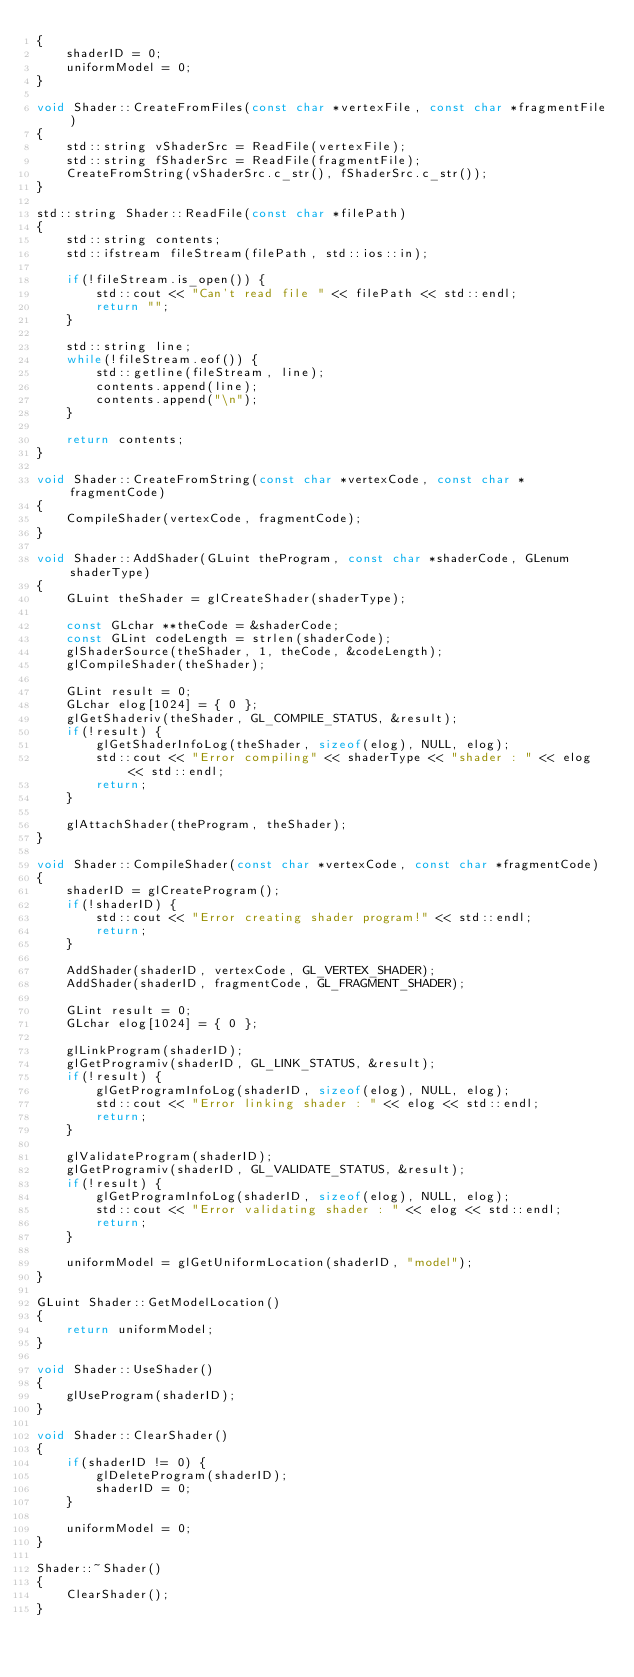<code> <loc_0><loc_0><loc_500><loc_500><_C++_>{
    shaderID = 0;
    uniformModel = 0;
}

void Shader::CreateFromFiles(const char *vertexFile, const char *fragmentFile)
{
    std::string vShaderSrc = ReadFile(vertexFile);
    std::string fShaderSrc = ReadFile(fragmentFile);
    CreateFromString(vShaderSrc.c_str(), fShaderSrc.c_str());
}

std::string Shader::ReadFile(const char *filePath)
{
    std::string contents;
    std::ifstream fileStream(filePath, std::ios::in);
    
    if(!fileStream.is_open()) {
        std::cout << "Can't read file " << filePath << std::endl;
        return "";
    }
    
    std::string line;
    while(!fileStream.eof()) {
        std::getline(fileStream, line);
        contents.append(line);
        contents.append("\n");
    }
    
    return contents;
}

void Shader::CreateFromString(const char *vertexCode, const char *fragmentCode)
{
    CompileShader(vertexCode, fragmentCode);
}

void Shader::AddShader(GLuint theProgram, const char *shaderCode, GLenum shaderType)
{
    GLuint theShader = glCreateShader(shaderType);

    const GLchar **theCode = &shaderCode;
    const GLint codeLength = strlen(shaderCode);
    glShaderSource(theShader, 1, theCode, &codeLength);
    glCompileShader(theShader);

    GLint result = 0;
    GLchar elog[1024] = { 0 };
    glGetShaderiv(theShader, GL_COMPILE_STATUS, &result);
    if(!result) {
        glGetShaderInfoLog(theShader, sizeof(elog), NULL, elog);
        std::cout << "Error compiling" << shaderType << "shader : " << elog << std::endl;
        return;
    }

    glAttachShader(theProgram, theShader);
}

void Shader::CompileShader(const char *vertexCode, const char *fragmentCode)
{
    shaderID = glCreateProgram();
    if(!shaderID) {
        std::cout << "Error creating shader program!" << std::endl;
        return;
    }

    AddShader(shaderID, vertexCode, GL_VERTEX_SHADER);
    AddShader(shaderID, fragmentCode, GL_FRAGMENT_SHADER);

    GLint result = 0;
    GLchar elog[1024] = { 0 };

    glLinkProgram(shaderID);
    glGetProgramiv(shaderID, GL_LINK_STATUS, &result);
    if(!result) {
        glGetProgramInfoLog(shaderID, sizeof(elog), NULL, elog);
        std::cout << "Error linking shader : " << elog << std::endl;
        return;
    }

    glValidateProgram(shaderID);
    glGetProgramiv(shaderID, GL_VALIDATE_STATUS, &result);
    if(!result) {
        glGetProgramInfoLog(shaderID, sizeof(elog), NULL, elog);
        std::cout << "Error validating shader : " << elog << std::endl;
        return;
    }

    uniformModel = glGetUniformLocation(shaderID, "model");
}

GLuint Shader::GetModelLocation()
{
    return uniformModel;
}

void Shader::UseShader()
{
    glUseProgram(shaderID);
}

void Shader::ClearShader()
{
    if(shaderID != 0) {
        glDeleteProgram(shaderID);
        shaderID = 0;
    }
    
    uniformModel = 0;
}

Shader::~Shader()
{
    ClearShader();
}
</code> 